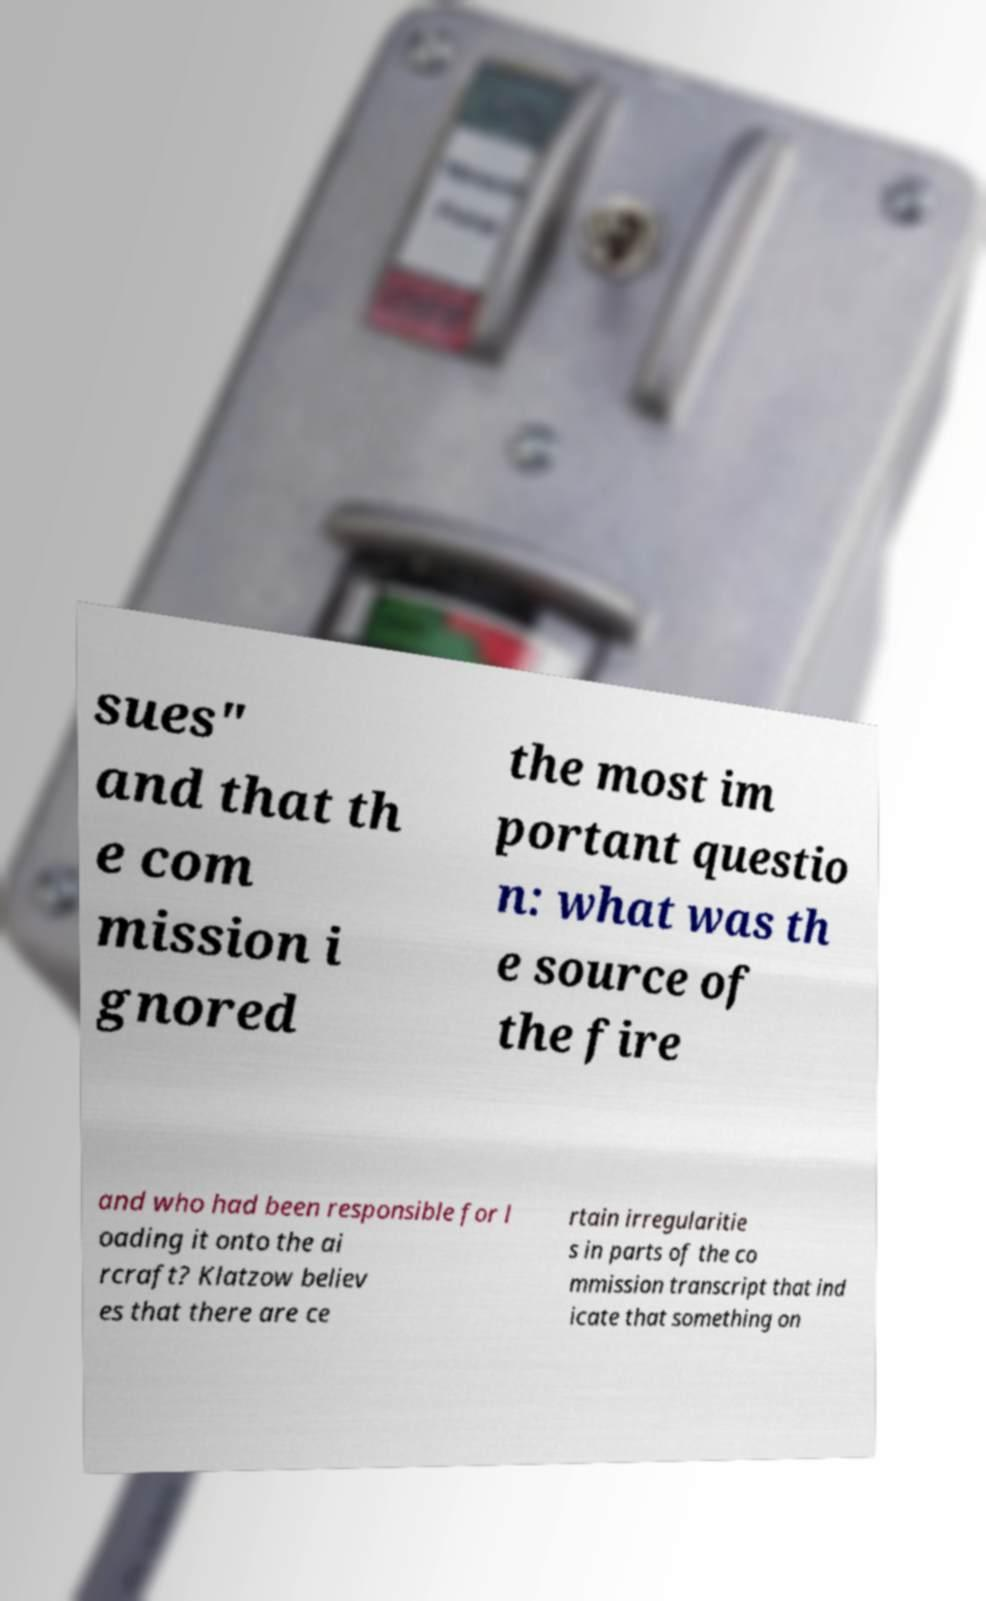Can you accurately transcribe the text from the provided image for me? sues" and that th e com mission i gnored the most im portant questio n: what was th e source of the fire and who had been responsible for l oading it onto the ai rcraft? Klatzow believ es that there are ce rtain irregularitie s in parts of the co mmission transcript that ind icate that something on 